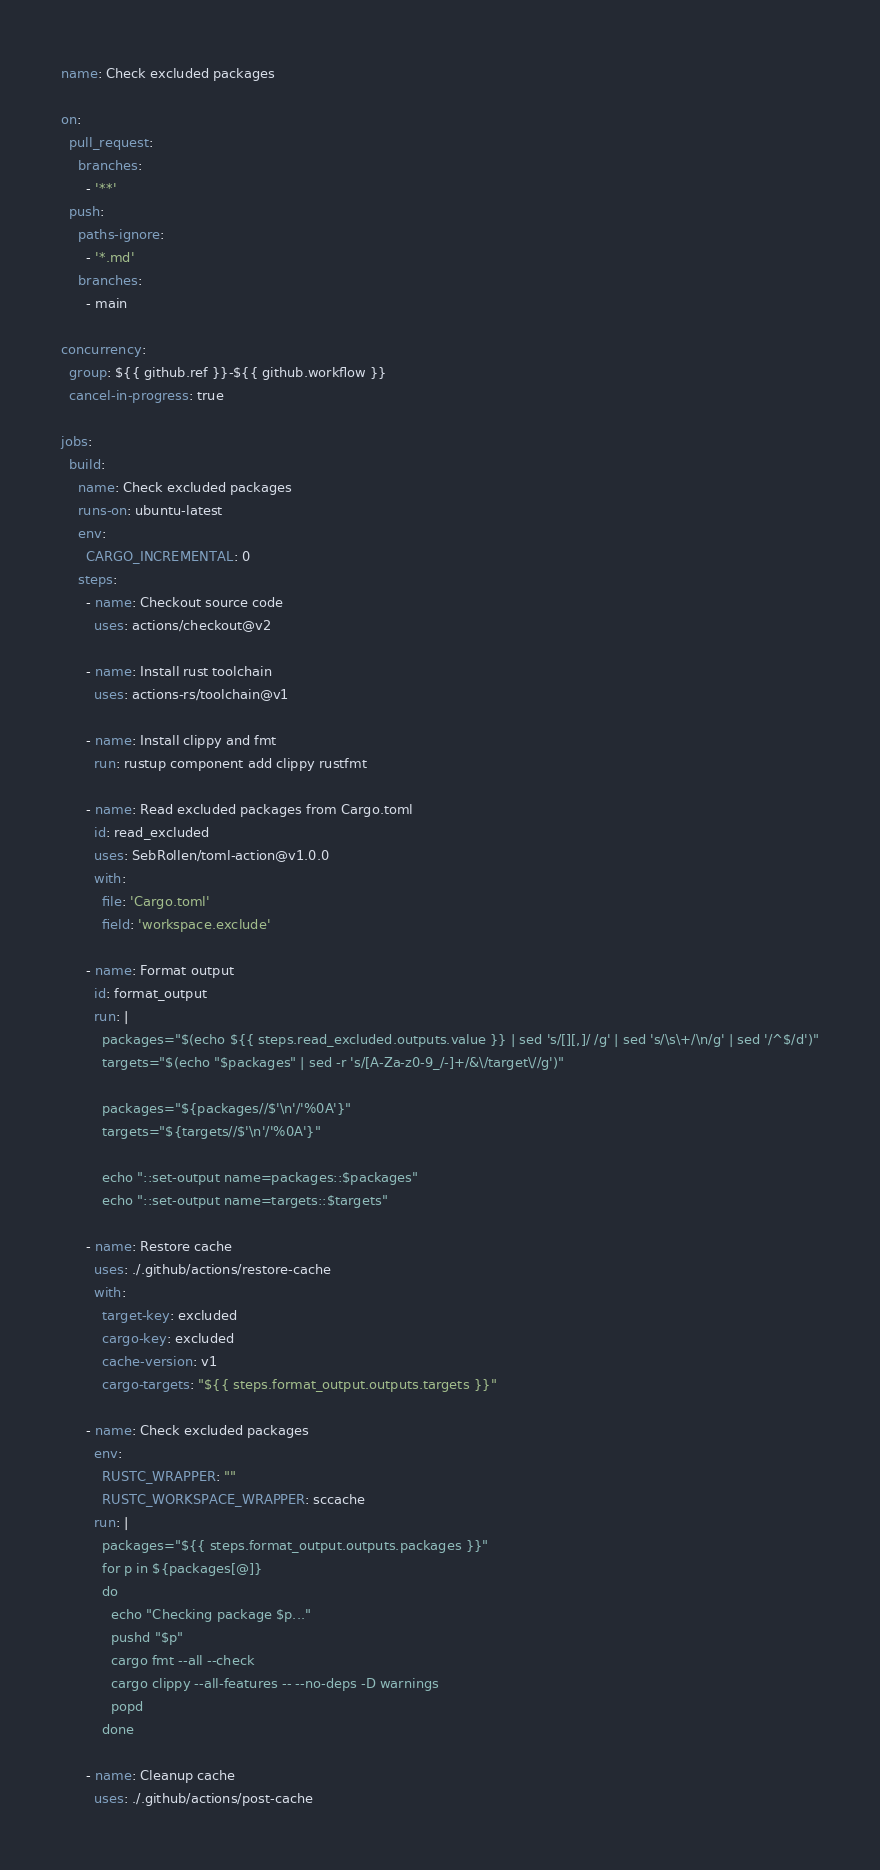Convert code to text. <code><loc_0><loc_0><loc_500><loc_500><_YAML_>name: Check excluded packages

on:
  pull_request:
    branches:
      - '**'
  push:
    paths-ignore:
      - '*.md'
    branches:
      - main

concurrency:
  group: ${{ github.ref }}-${{ github.workflow }}
  cancel-in-progress: true

jobs:
  build:
    name: Check excluded packages
    runs-on: ubuntu-latest
    env:
      CARGO_INCREMENTAL: 0
    steps:
      - name: Checkout source code
        uses: actions/checkout@v2

      - name: Install rust toolchain
        uses: actions-rs/toolchain@v1

      - name: Install clippy and fmt
        run: rustup component add clippy rustfmt

      - name: Read excluded packages from Cargo.toml
        id: read_excluded
        uses: SebRollen/toml-action@v1.0.0
        with:
          file: 'Cargo.toml'
          field: 'workspace.exclude'

      - name: Format output
        id: format_output
        run: |
          packages="$(echo ${{ steps.read_excluded.outputs.value }} | sed 's/[][,]/ /g' | sed 's/\s\+/\n/g' | sed '/^$/d')"
          targets="$(echo "$packages" | sed -r 's/[A-Za-z0-9_/-]+/&\/target\//g')"

          packages="${packages//$'\n'/'%0A'}"
          targets="${targets//$'\n'/'%0A'}"

          echo "::set-output name=packages::$packages"
          echo "::set-output name=targets::$targets"

      - name: Restore cache
        uses: ./.github/actions/restore-cache
        with:
          target-key: excluded
          cargo-key: excluded
          cache-version: v1
          cargo-targets: "${{ steps.format_output.outputs.targets }}"

      - name: Check excluded packages
        env:
          RUSTC_WRAPPER: ""
          RUSTC_WORKSPACE_WRAPPER: sccache
        run: |
          packages="${{ steps.format_output.outputs.packages }}"
          for p in ${packages[@]}
          do
            echo "Checking package $p..."
            pushd "$p"
            cargo fmt --all --check
            cargo clippy --all-features -- --no-deps -D warnings
            popd
          done

      - name: Cleanup cache
        uses: ./.github/actions/post-cache
</code> 